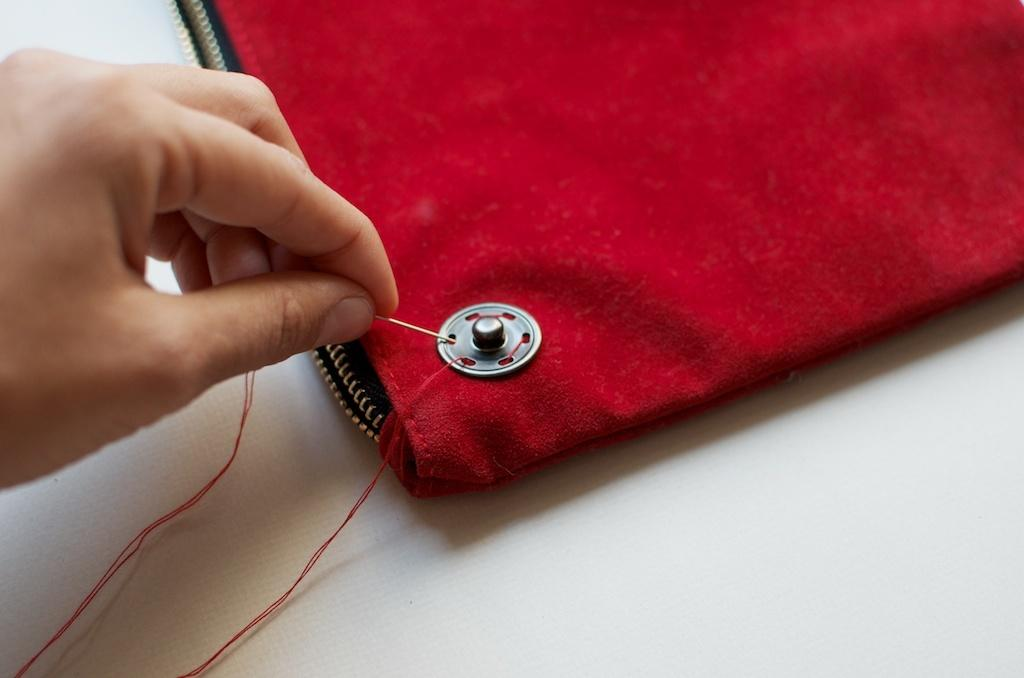What is the person's hand holding in the image? The hand is holding a needle in the image. Is there any other object near the hand? There may be a bag in front of the hand. What can be seen on the bag? There is a button on the bag. What else is visible in the image related to sewing? Thread is visible in the image. What type of advertisement is displayed on the person's legs in the image? There is no advertisement displayed on the person's legs in the image, as the facts provided do not mention any legs or advertisements. 